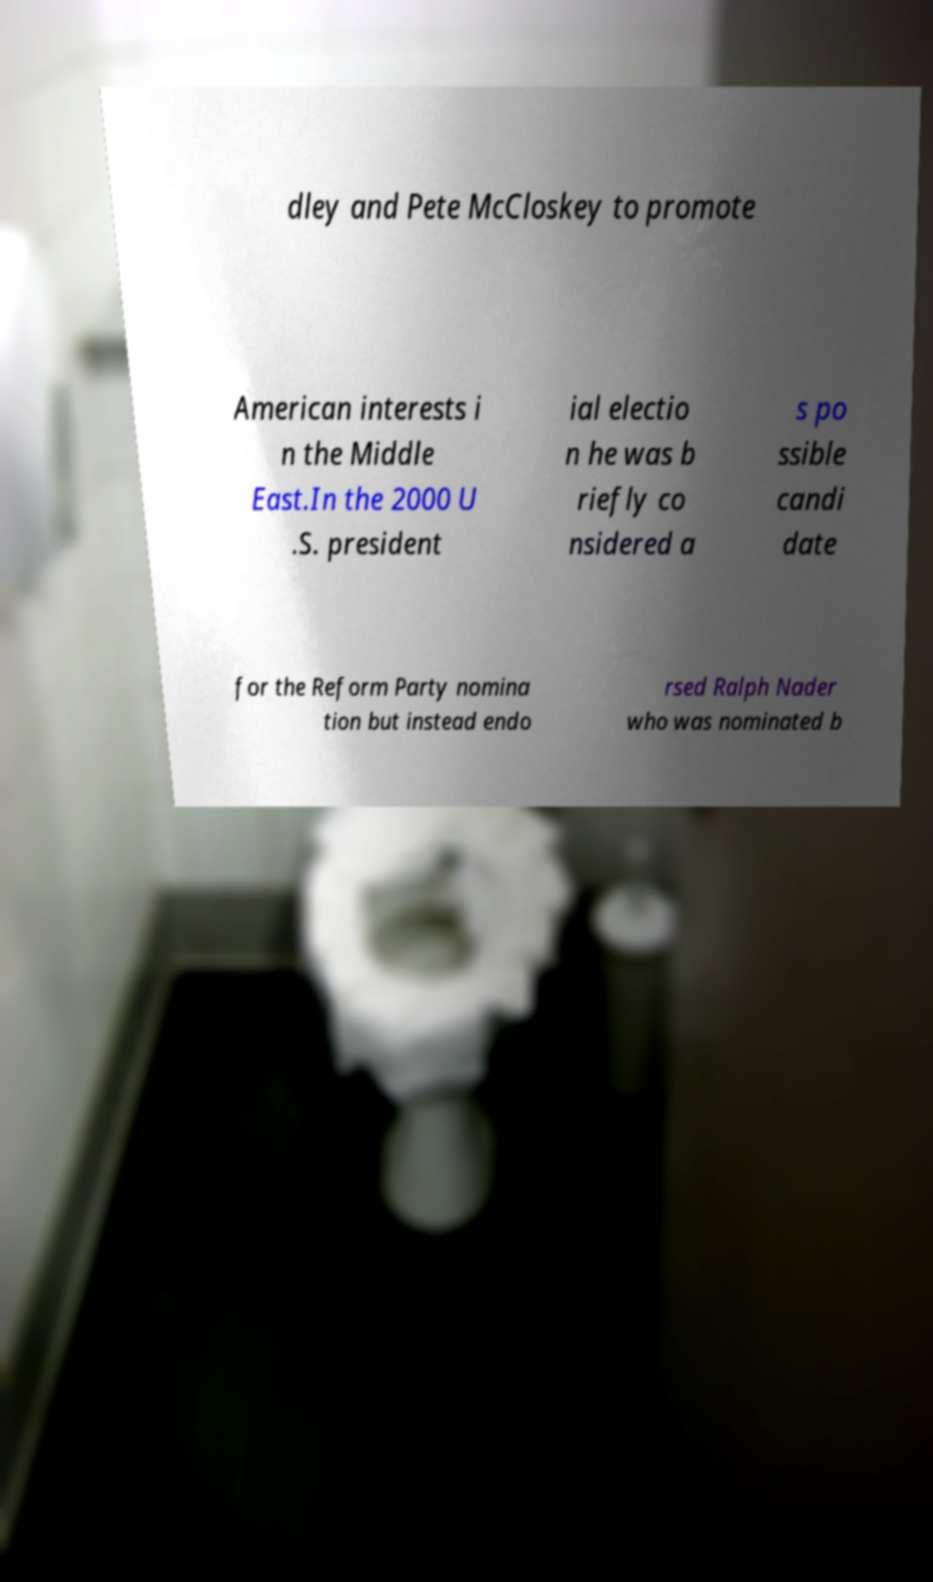Could you extract and type out the text from this image? dley and Pete McCloskey to promote American interests i n the Middle East.In the 2000 U .S. president ial electio n he was b riefly co nsidered a s po ssible candi date for the Reform Party nomina tion but instead endo rsed Ralph Nader who was nominated b 